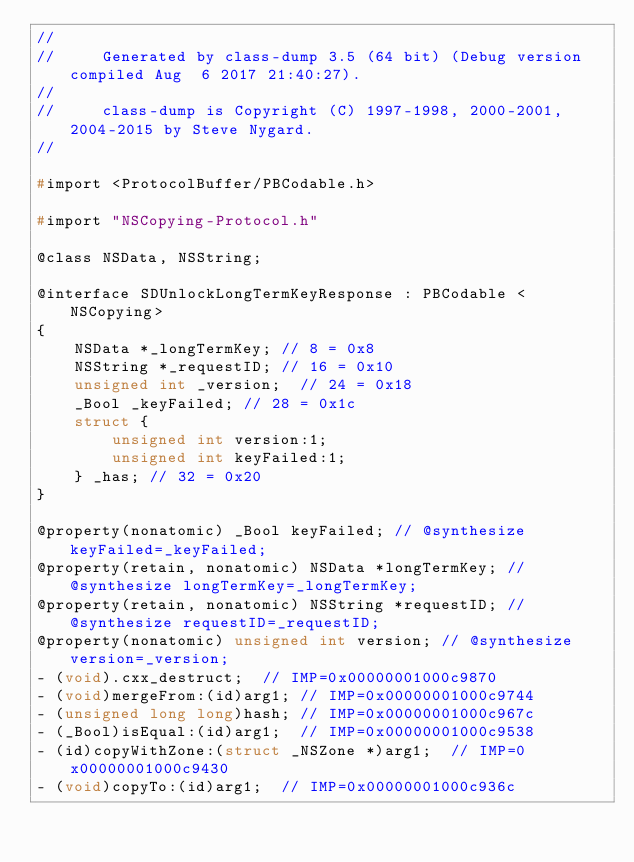<code> <loc_0><loc_0><loc_500><loc_500><_C_>//
//     Generated by class-dump 3.5 (64 bit) (Debug version compiled Aug  6 2017 21:40:27).
//
//     class-dump is Copyright (C) 1997-1998, 2000-2001, 2004-2015 by Steve Nygard.
//

#import <ProtocolBuffer/PBCodable.h>

#import "NSCopying-Protocol.h"

@class NSData, NSString;

@interface SDUnlockLongTermKeyResponse : PBCodable <NSCopying>
{
    NSData *_longTermKey;	// 8 = 0x8
    NSString *_requestID;	// 16 = 0x10
    unsigned int _version;	// 24 = 0x18
    _Bool _keyFailed;	// 28 = 0x1c
    struct {
        unsigned int version:1;
        unsigned int keyFailed:1;
    } _has;	// 32 = 0x20
}

@property(nonatomic) _Bool keyFailed; // @synthesize keyFailed=_keyFailed;
@property(retain, nonatomic) NSData *longTermKey; // @synthesize longTermKey=_longTermKey;
@property(retain, nonatomic) NSString *requestID; // @synthesize requestID=_requestID;
@property(nonatomic) unsigned int version; // @synthesize version=_version;
- (void).cxx_destruct;	// IMP=0x00000001000c9870
- (void)mergeFrom:(id)arg1;	// IMP=0x00000001000c9744
- (unsigned long long)hash;	// IMP=0x00000001000c967c
- (_Bool)isEqual:(id)arg1;	// IMP=0x00000001000c9538
- (id)copyWithZone:(struct _NSZone *)arg1;	// IMP=0x00000001000c9430
- (void)copyTo:(id)arg1;	// IMP=0x00000001000c936c</code> 